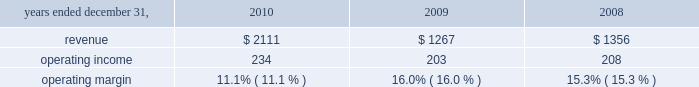Hr solutions .
In october 2010 , we completed the acquisition of hewitt , one of the world 2019s leading human resource consulting and outsourcing companies .
Hewitt operates globally together with aon 2019s existing consulting and outsourcing operations under the newly created aon hewitt brand .
Hewitt 2019s operating results are included in aon 2019s results of operations beginning october 1 , 2010 .
Our hr solutions segment generated approximately 25% ( 25 % ) of our consolidated total revenues in 2010 and provides a broad range of human capital services , as follows : consulting services : 2022 health and benefits advises clients about how to structure , fund , and administer employee benefit programs that attract , retain , and motivate employees .
Benefits consulting includes health and welfare , executive benefits , workforce strategies and productivity , absence management , benefits administration , data-driven health , compliance , employee commitment , investment advisory and elective benefits services .
2022 retirement specializes in global actuarial services , defined contribution consulting , investment consulting , tax and erisa consulting , and pension administration .
2022 compensation focuses on compensatory advisory/counsel including : compensation planning design , executive reward strategies , salary survey and benchmarking , market share studies and sales force effectiveness , with special expertise in the financial services and technology industries .
2022 strategic human capital delivers advice to complex global organizations on talent , change and organizational effectiveness issues , including talent strategy and acquisition , executive on-boarding , performance management , leadership assessment and development , communication strategy , workforce training and change management .
Outsourcing services : 2022 benefits outsourcing applies our hr expertise primarily through defined benefit ( pension ) , defined contribution ( 401 ( k ) ) , and health and welfare administrative services .
Our model replaces the resource-intensive processes once required to administer benefit plans with more efficient , effective , and less costly solutions .
2022 human resource business processing outsourcing ( 2018 2018hr bpo 2019 2019 ) provides market-leading solutions to manage employee data ; administer benefits , payroll and other human resources processes ; and record and manage talent , workforce and other core hr process transactions as well as other complementary services such as absence management , flexible spending , dependent audit and participant advocacy .
Beginning in late 2008 , the disruption in the global credit markets and the deterioration of the financial markets created significant uncertainty in the marketplace .
Weak economic conditions globally continued throughout 2010 .
The prolonged economic downturn is adversely impacting our clients 2019 financial condition and therefore the levels of business activities in the industries and geographies where we operate .
While we believe that the majority of our practices are well positioned to manage through this time , these challenges are reducing demand for some of our services and putting .
What was the percentage change in the revenues from 2009 to 2010? 
Computations: ((2111 - 1267) / 1267)
Answer: 0.66614. 